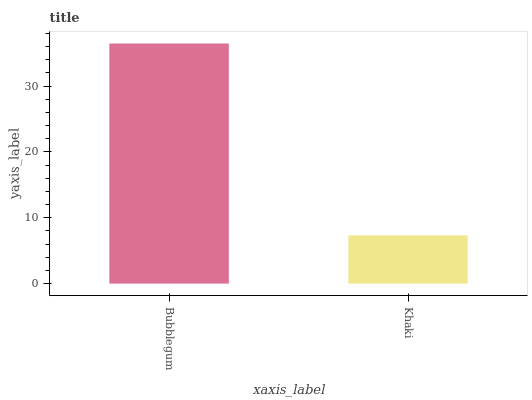Is Khaki the minimum?
Answer yes or no. Yes. Is Bubblegum the maximum?
Answer yes or no. Yes. Is Khaki the maximum?
Answer yes or no. No. Is Bubblegum greater than Khaki?
Answer yes or no. Yes. Is Khaki less than Bubblegum?
Answer yes or no. Yes. Is Khaki greater than Bubblegum?
Answer yes or no. No. Is Bubblegum less than Khaki?
Answer yes or no. No. Is Bubblegum the high median?
Answer yes or no. Yes. Is Khaki the low median?
Answer yes or no. Yes. Is Khaki the high median?
Answer yes or no. No. Is Bubblegum the low median?
Answer yes or no. No. 